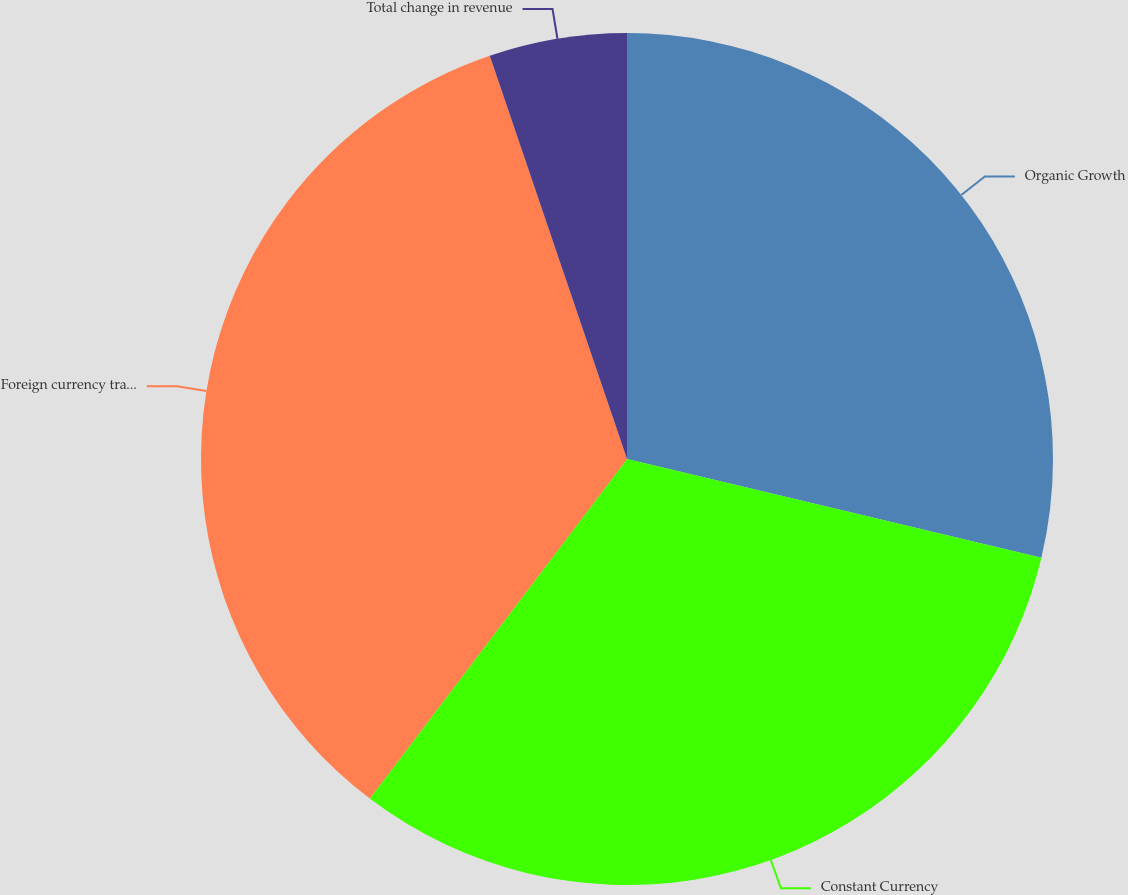Convert chart. <chart><loc_0><loc_0><loc_500><loc_500><pie_chart><fcel>Organic Growth<fcel>Constant Currency<fcel>Foreign currency translation<fcel>Total change in revenue<nl><fcel>28.72%<fcel>31.59%<fcel>34.46%<fcel>5.22%<nl></chart> 